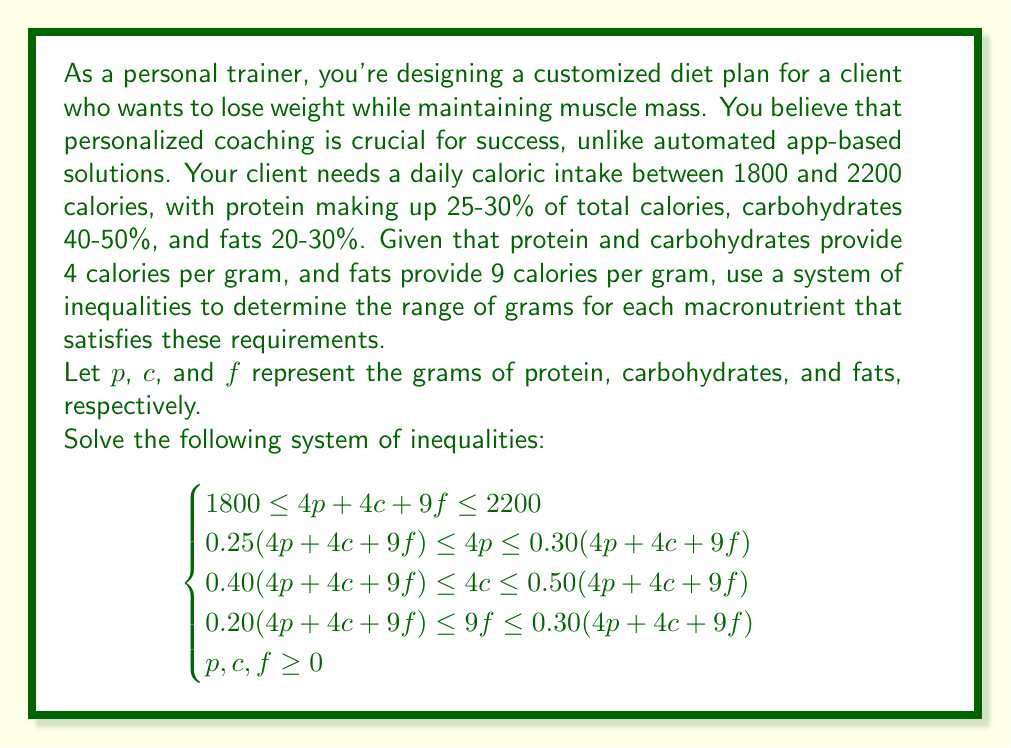Give your solution to this math problem. Let's solve this system of inequalities step by step:

1) First, we'll simplify the total calorie inequality:
   $$1800 \leq 4p + 4c + 9f \leq 2200$$

2) For protein (25-30% of total calories):
   $$0.25(4p + 4c + 9f) \leq 4p \leq 0.30(4p + 4c + 9f)$$
   Dividing by 4:
   $$112.5 \leq p \leq 165$$

3) For carbohydrates (40-50% of total calories):
   $$0.40(4p + 4c + 9f) \leq 4c \leq 0.50(4p + 4c + 9f)$$
   Dividing by 4:
   $$180 \leq c \leq 275$$

4) For fats (20-30% of total calories):
   $$0.20(4p + 4c + 9f) \leq 9f \leq 0.30(4p + 4c + 9f)$$
   Dividing by 9:
   $$40 \leq f \leq 73.33$$

5) Now, we need to ensure that the total calories fall within the 1800-2200 range:
   $$1800 \leq 4p + 4c + 9f \leq 2200$$

   Using the minimum values: $4(112.5) + 4(180) + 9(40) = 1810$
   Using the maximum values: $4(165) + 4(275) + 9(73.33) \approx 2199.97$

   Both extremes satisfy the total calorie requirement.

6) Therefore, the solution to the system of inequalities is:
   $$\begin{cases}
   112.5 \leq p \leq 165 \\
   180 \leq c \leq 275 \\
   40 \leq f \leq 73.33 \\
   \end{cases}$$

This solution provides a range for each macronutrient that satisfies all the given constraints.
Answer: The ideal macronutrient balance for the client's diet plan is:

Protein: $112.5 \leq p \leq 165$ grams
Carbohydrates: $180 \leq c \leq 275$ grams
Fats: $40 \leq f \leq 73.33$ grams

Where $p$, $c$, and $f$ represent the grams of protein, carbohydrates, and fats, respectively. 